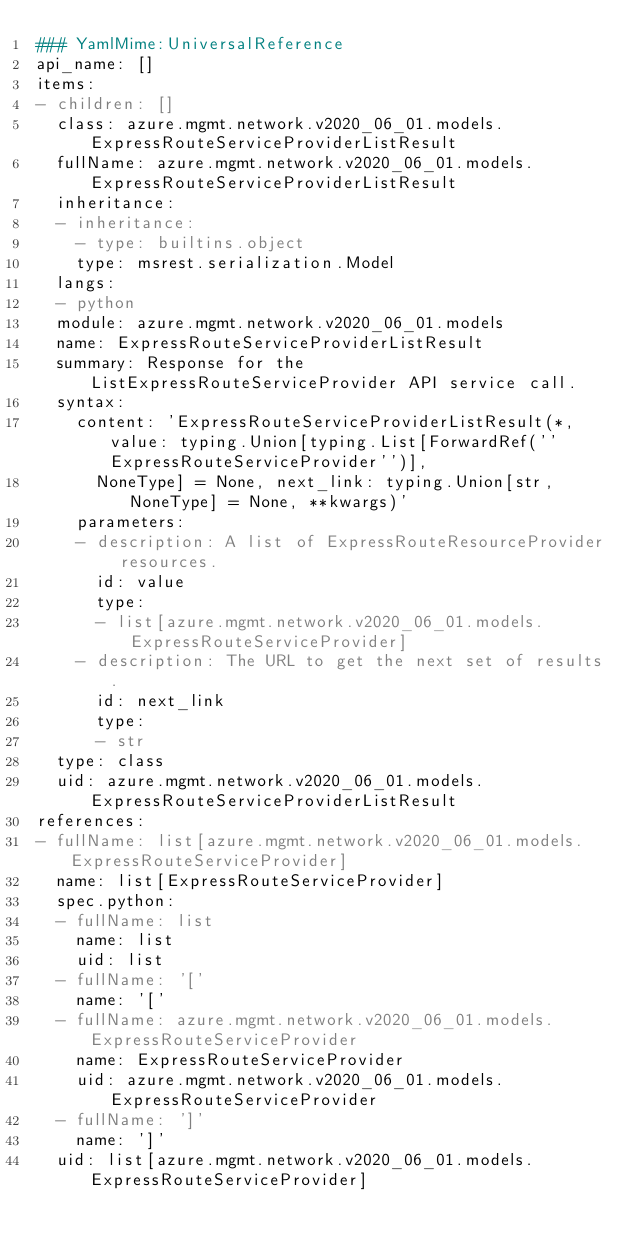<code> <loc_0><loc_0><loc_500><loc_500><_YAML_>### YamlMime:UniversalReference
api_name: []
items:
- children: []
  class: azure.mgmt.network.v2020_06_01.models.ExpressRouteServiceProviderListResult
  fullName: azure.mgmt.network.v2020_06_01.models.ExpressRouteServiceProviderListResult
  inheritance:
  - inheritance:
    - type: builtins.object
    type: msrest.serialization.Model
  langs:
  - python
  module: azure.mgmt.network.v2020_06_01.models
  name: ExpressRouteServiceProviderListResult
  summary: Response for the ListExpressRouteServiceProvider API service call.
  syntax:
    content: 'ExpressRouteServiceProviderListResult(*, value: typing.Union[typing.List[ForwardRef(''ExpressRouteServiceProvider'')],
      NoneType] = None, next_link: typing.Union[str, NoneType] = None, **kwargs)'
    parameters:
    - description: A list of ExpressRouteResourceProvider resources.
      id: value
      type:
      - list[azure.mgmt.network.v2020_06_01.models.ExpressRouteServiceProvider]
    - description: The URL to get the next set of results.
      id: next_link
      type:
      - str
  type: class
  uid: azure.mgmt.network.v2020_06_01.models.ExpressRouteServiceProviderListResult
references:
- fullName: list[azure.mgmt.network.v2020_06_01.models.ExpressRouteServiceProvider]
  name: list[ExpressRouteServiceProvider]
  spec.python:
  - fullName: list
    name: list
    uid: list
  - fullName: '['
    name: '['
  - fullName: azure.mgmt.network.v2020_06_01.models.ExpressRouteServiceProvider
    name: ExpressRouteServiceProvider
    uid: azure.mgmt.network.v2020_06_01.models.ExpressRouteServiceProvider
  - fullName: ']'
    name: ']'
  uid: list[azure.mgmt.network.v2020_06_01.models.ExpressRouteServiceProvider]
</code> 